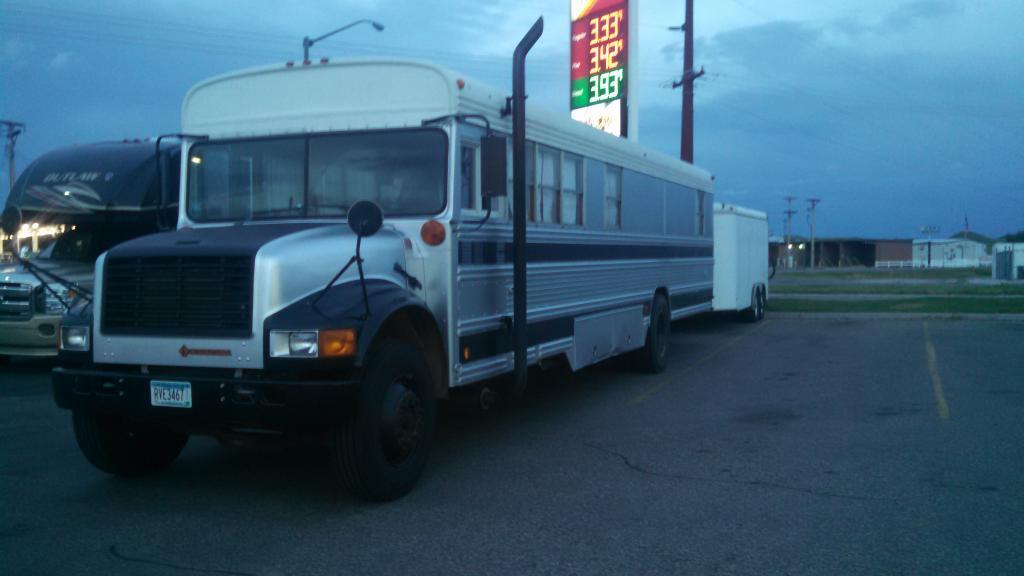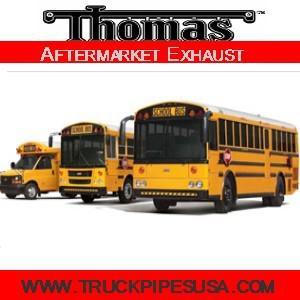The first image is the image on the left, the second image is the image on the right. For the images displayed, is the sentence "The left and right image contains the same number of buses." factually correct? Answer yes or no. No. 